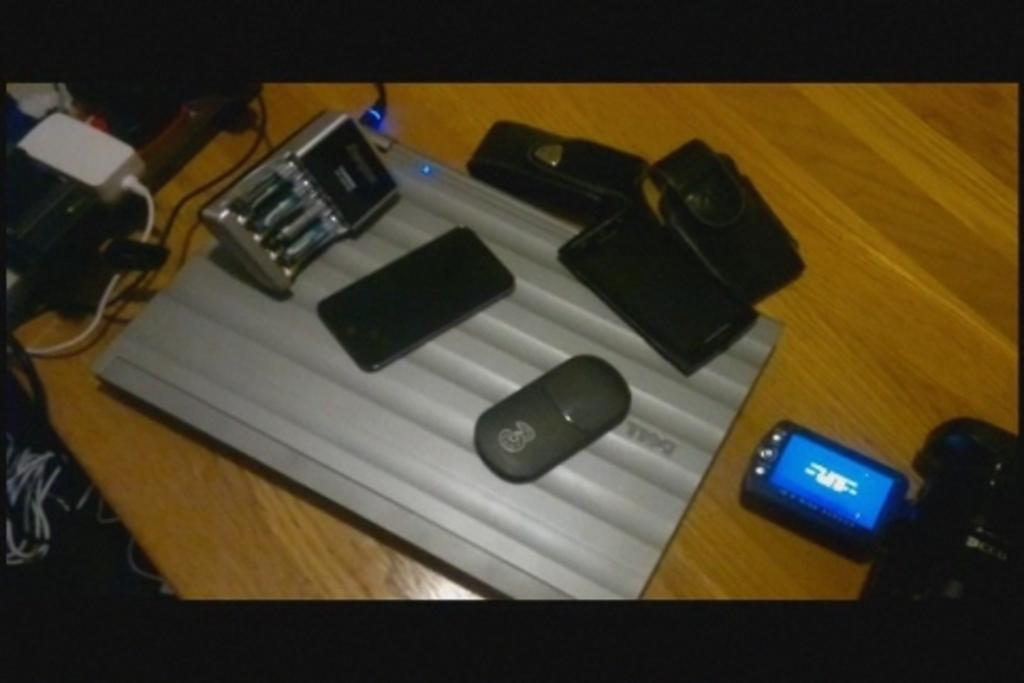What is the main subject of the image? The main subject of the image is objects placed on a table. Can you describe any specific objects on the table? Yes, there is an extension box on the table, and some plugs are plugged into it. What other object can be seen on the table? There is a digital camera on the table. What type of birthday celebration is taking place on the coast in the image? There is no birthday celebration or coast present in the image; it only shows objects placed on a table. 